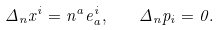<formula> <loc_0><loc_0><loc_500><loc_500>\Delta _ { n } x ^ { i } = n ^ { a } e _ { a } ^ { i } , \quad \Delta _ { n } p _ { i } = 0 .</formula> 